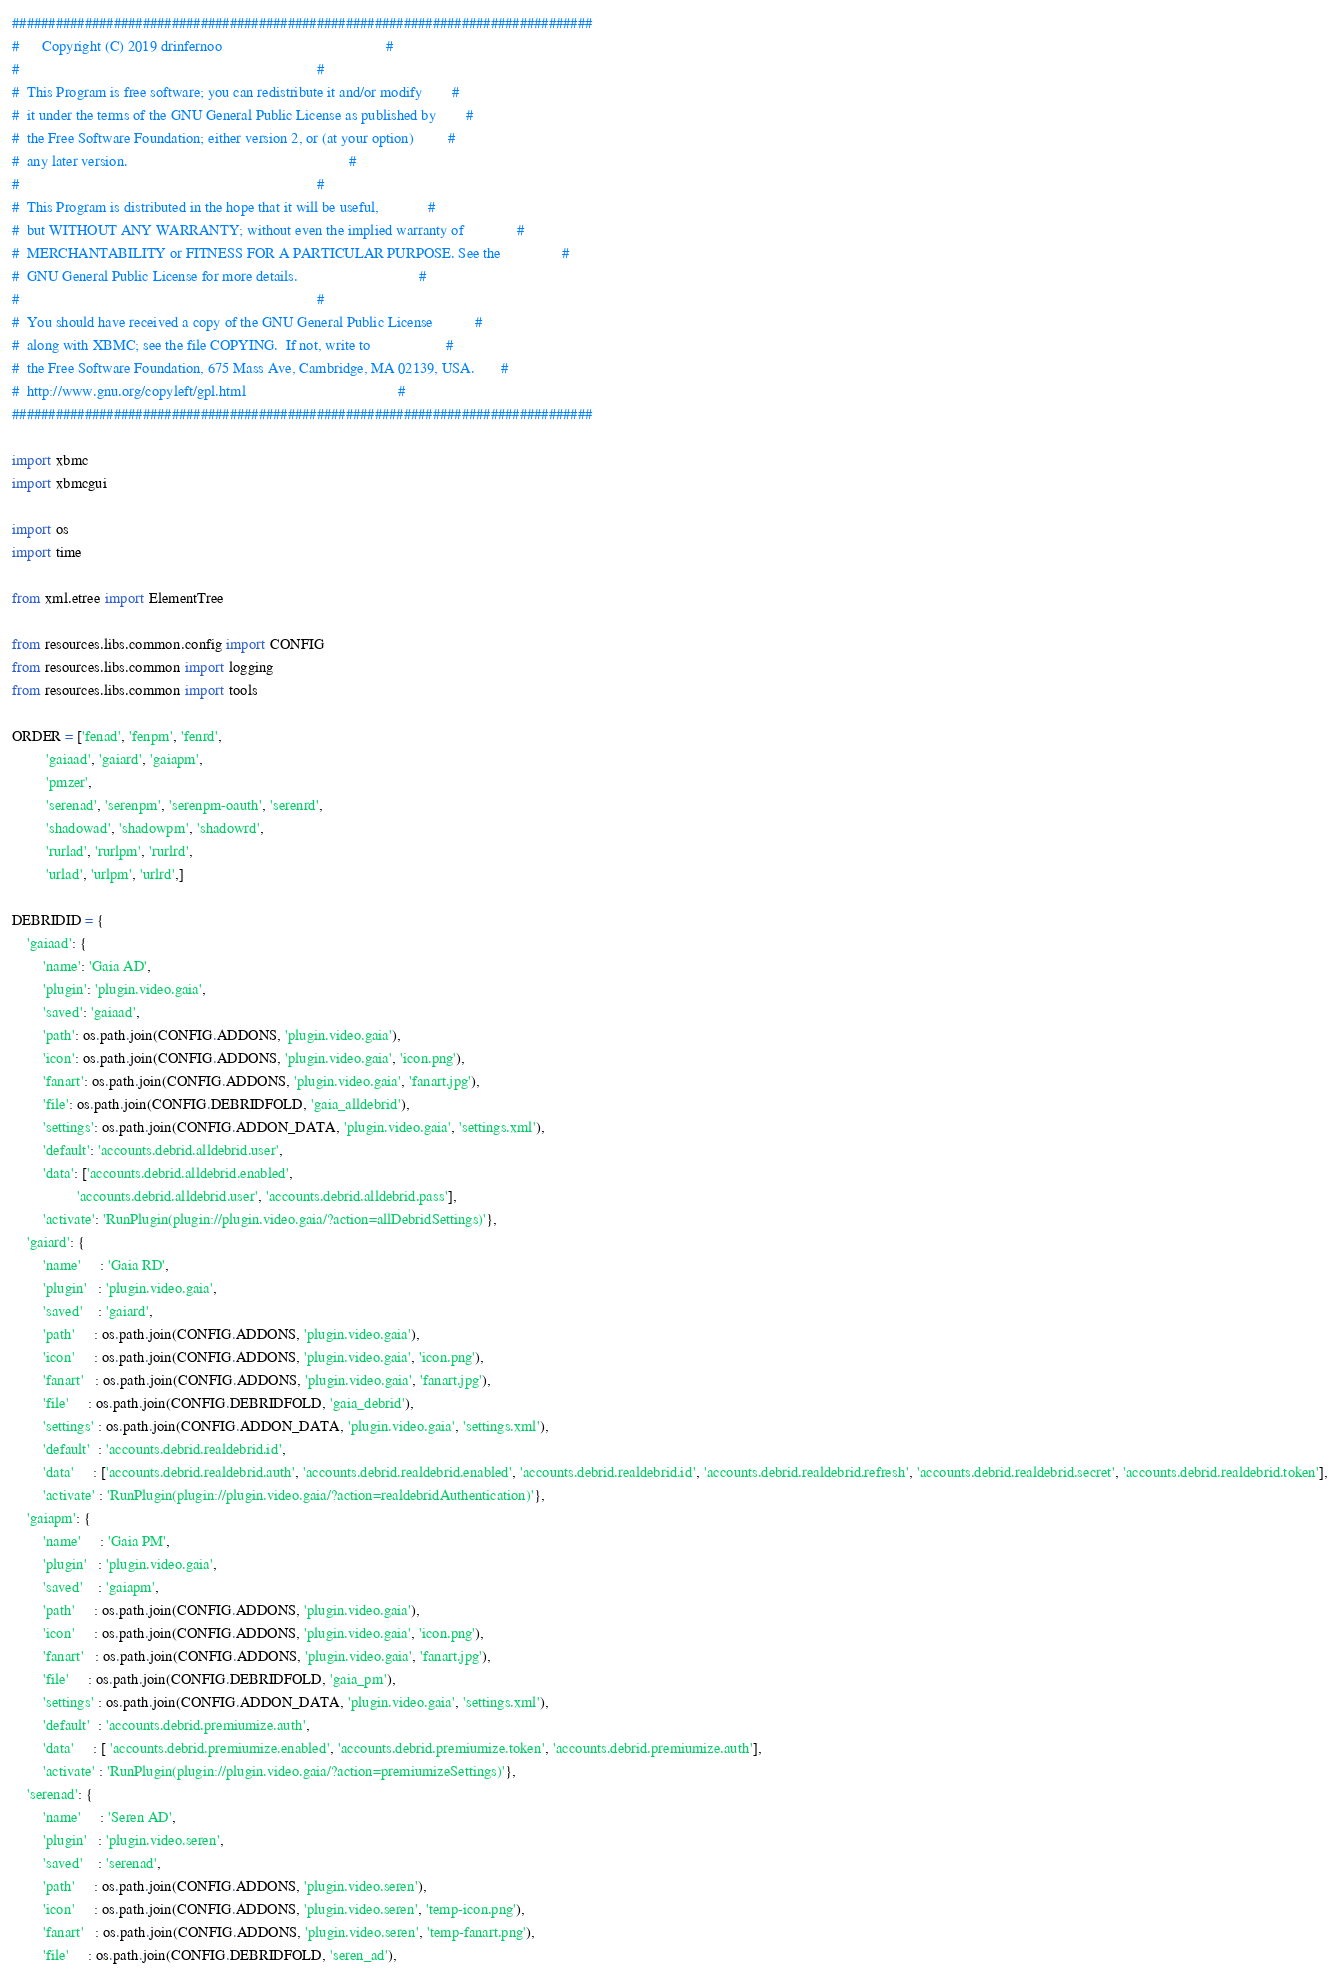<code> <loc_0><loc_0><loc_500><loc_500><_Python_>################################################################################
#      Copyright (C) 2019 drinfernoo                                           #
#                                                                              #
#  This Program is free software; you can redistribute it and/or modify        #
#  it under the terms of the GNU General Public License as published by        #
#  the Free Software Foundation; either version 2, or (at your option)         #
#  any later version.                                                          #
#                                                                              #
#  This Program is distributed in the hope that it will be useful,             #
#  but WITHOUT ANY WARRANTY; without even the implied warranty of              #
#  MERCHANTABILITY or FITNESS FOR A PARTICULAR PURPOSE. See the                #
#  GNU General Public License for more details.                                #
#                                                                              #
#  You should have received a copy of the GNU General Public License           #
#  along with XBMC; see the file COPYING.  If not, write to                    #
#  the Free Software Foundation, 675 Mass Ave, Cambridge, MA 02139, USA.       #
#  http://www.gnu.org/copyleft/gpl.html                                        #
################################################################################

import xbmc
import xbmcgui

import os
import time

from xml.etree import ElementTree

from resources.libs.common.config import CONFIG
from resources.libs.common import logging
from resources.libs.common import tools

ORDER = ['fenad', 'fenpm', 'fenrd',
         'gaiaad', 'gaiard', 'gaiapm',
         'pmzer',
         'serenad', 'serenpm', 'serenpm-oauth', 'serenrd', 
         'shadowad', 'shadowpm', 'shadowrd',
         'rurlad', 'rurlpm', 'rurlrd',
         'urlad', 'urlpm', 'urlrd',]

DEBRIDID = {
    'gaiaad': {
        'name': 'Gaia AD',
        'plugin': 'plugin.video.gaia',
        'saved': 'gaiaad',
        'path': os.path.join(CONFIG.ADDONS, 'plugin.video.gaia'),
        'icon': os.path.join(CONFIG.ADDONS, 'plugin.video.gaia', 'icon.png'),
        'fanart': os.path.join(CONFIG.ADDONS, 'plugin.video.gaia', 'fanart.jpg'),
        'file': os.path.join(CONFIG.DEBRIDFOLD, 'gaia_alldebrid'),
        'settings': os.path.join(CONFIG.ADDON_DATA, 'plugin.video.gaia', 'settings.xml'),
        'default': 'accounts.debrid.alldebrid.user',
        'data': ['accounts.debrid.alldebrid.enabled',
                 'accounts.debrid.alldebrid.user', 'accounts.debrid.alldebrid.pass'],
        'activate': 'RunPlugin(plugin://plugin.video.gaia/?action=allDebridSettings)'},
    'gaiard': {
        'name'     : 'Gaia RD',
        'plugin'   : 'plugin.video.gaia',
        'saved'    : 'gaiard',
        'path'     : os.path.join(CONFIG.ADDONS, 'plugin.video.gaia'),
        'icon'     : os.path.join(CONFIG.ADDONS, 'plugin.video.gaia', 'icon.png'),
        'fanart'   : os.path.join(CONFIG.ADDONS, 'plugin.video.gaia', 'fanart.jpg'),
        'file'     : os.path.join(CONFIG.DEBRIDFOLD, 'gaia_debrid'),
        'settings' : os.path.join(CONFIG.ADDON_DATA, 'plugin.video.gaia', 'settings.xml'),
        'default'  : 'accounts.debrid.realdebrid.id',
        'data'     : ['accounts.debrid.realdebrid.auth', 'accounts.debrid.realdebrid.enabled', 'accounts.debrid.realdebrid.id', 'accounts.debrid.realdebrid.refresh', 'accounts.debrid.realdebrid.secret', 'accounts.debrid.realdebrid.token'],
        'activate' : 'RunPlugin(plugin://plugin.video.gaia/?action=realdebridAuthentication)'},
    'gaiapm': {
        'name'     : 'Gaia PM',
        'plugin'   : 'plugin.video.gaia',
        'saved'    : 'gaiapm',
        'path'     : os.path.join(CONFIG.ADDONS, 'plugin.video.gaia'),
        'icon'     : os.path.join(CONFIG.ADDONS, 'plugin.video.gaia', 'icon.png'),
        'fanart'   : os.path.join(CONFIG.ADDONS, 'plugin.video.gaia', 'fanart.jpg'),
        'file'     : os.path.join(CONFIG.DEBRIDFOLD, 'gaia_pm'),
        'settings' : os.path.join(CONFIG.ADDON_DATA, 'plugin.video.gaia', 'settings.xml'),
        'default'  : 'accounts.debrid.premiumize.auth',
        'data'     : [ 'accounts.debrid.premiumize.enabled', 'accounts.debrid.premiumize.token', 'accounts.debrid.premiumize.auth'],
        'activate' : 'RunPlugin(plugin://plugin.video.gaia/?action=premiumizeSettings)'},
    'serenad': {
        'name'     : 'Seren AD',
        'plugin'   : 'plugin.video.seren',
        'saved'    : 'serenad',
        'path'     : os.path.join(CONFIG.ADDONS, 'plugin.video.seren'),
        'icon'     : os.path.join(CONFIG.ADDONS, 'plugin.video.seren', 'temp-icon.png'),
        'fanart'   : os.path.join(CONFIG.ADDONS, 'plugin.video.seren', 'temp-fanart.png'),
        'file'     : os.path.join(CONFIG.DEBRIDFOLD, 'seren_ad'),</code> 